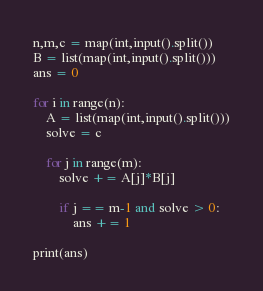Convert code to text. <code><loc_0><loc_0><loc_500><loc_500><_Python_>n,m,c = map(int,input().split())
B = list(map(int,input().split()))
ans = 0

for i in range(n):
    A = list(map(int,input().split()))
    solve = c

    for j in range(m):
        solve += A[j]*B[j]
        
        if j == m-1 and solve > 0:
            ans += 1
            
print(ans)</code> 